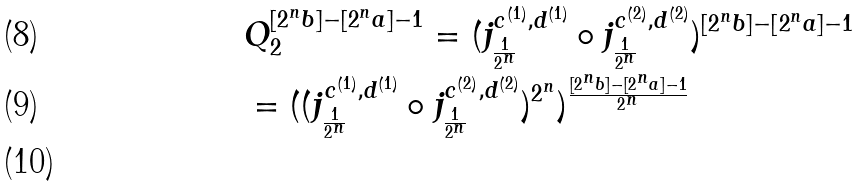<formula> <loc_0><loc_0><loc_500><loc_500>& Q _ { 2 } ^ { [ 2 ^ { n } b ] - [ 2 ^ { n } a ] - 1 } = ( j ^ { c ^ { ( 1 ) } , d ^ { ( 1 ) } } _ { \frac { 1 } { 2 ^ { n } } } \circ j ^ { c ^ { ( 2 ) } , d ^ { ( 2 ) } } _ { \frac { 1 } { 2 ^ { n } } } ) ^ { [ 2 ^ { n } b ] - [ 2 ^ { n } a ] - 1 } \\ & = ( ( j ^ { c ^ { ( 1 ) } , d ^ { ( 1 ) } } _ { \frac { 1 } { 2 ^ { n } } } \circ j ^ { c ^ { ( 2 ) } , d ^ { ( 2 ) } } _ { \frac { 1 } { 2 ^ { n } } } ) ^ { 2 ^ { n } } ) ^ { \frac { [ 2 ^ { n } b ] - [ 2 ^ { n } a ] - 1 } { 2 ^ { n } } } \\</formula> 